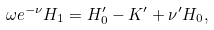Convert formula to latex. <formula><loc_0><loc_0><loc_500><loc_500>\omega e ^ { - \nu } H _ { 1 } = H ^ { \prime } _ { 0 } - K ^ { \prime } + \nu ^ { \prime } H _ { 0 } ,</formula> 